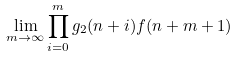Convert formula to latex. <formula><loc_0><loc_0><loc_500><loc_500>\lim _ { m \to \infty } \prod _ { i = 0 } ^ { m } g _ { 2 } ( n + i ) f ( n + m + 1 )</formula> 